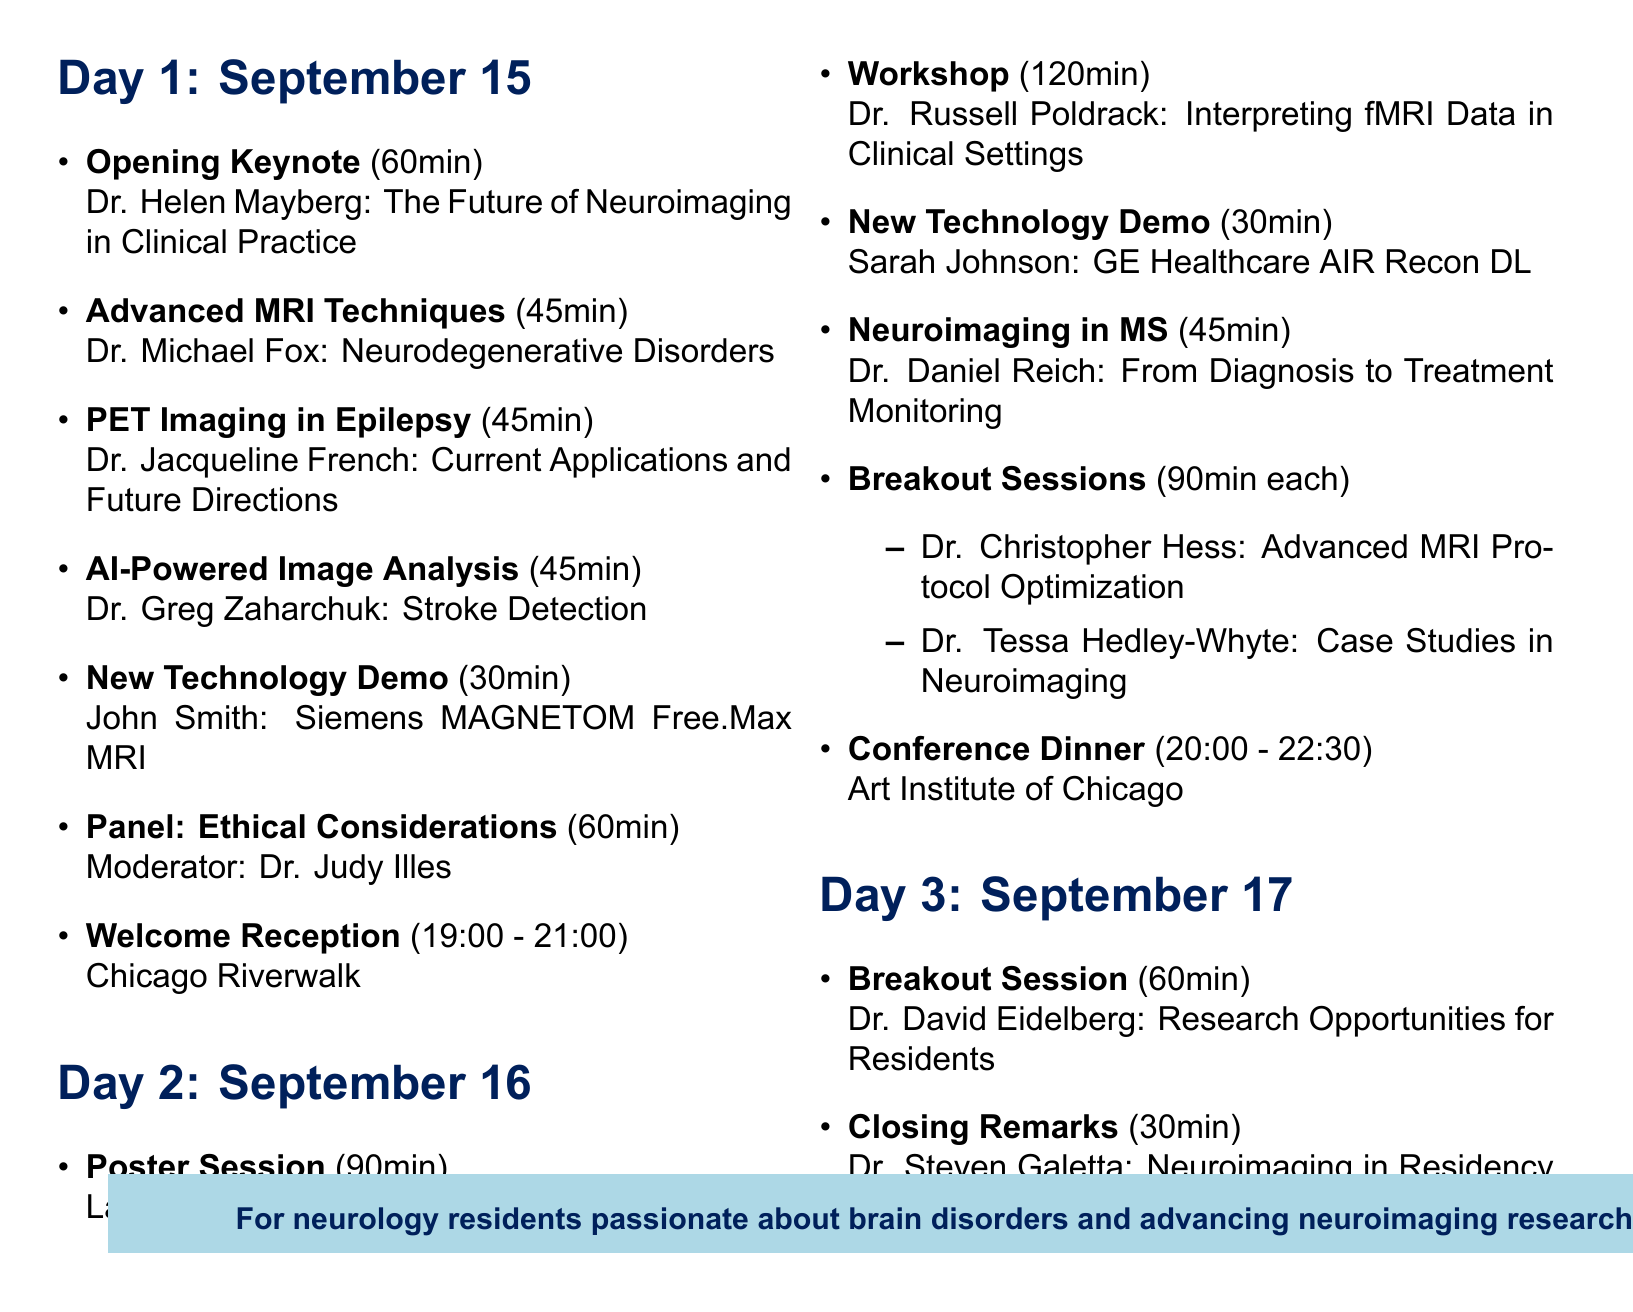What are the dates of the conference? The conference dates are mentioned clearly in the document as September 15-17, 2023.
Answer: September 15-17, 2023 Who is the speaker for the workshop on interpreting fMRI data? The document lists the facilitator for the workshop, which is Dr. Russell Poldrack from Stanford University.
Answer: Dr. Russell Poldrack How long is the closing remarks session? The duration of the closing remarks is specified in the document as 30 minutes.
Answer: 30 minutes Which venue will host the conference dinner? The venue for the conference dinner is stated as the Art Institute of Chicago in the document.
Answer: Art Institute of Chicago What is the duration of the poster session? The document specifies the poster session's duration as 90 minutes.
Answer: 90 minutes Who is moderating the panel discussion? The moderator for the panel discussion is mentioned as Dr. Judy Illes from the University of British Columbia.
Answer: Dr. Judy Illes What type of event is scheduled for September 15 from 19:00 to 21:00? The specific type of event during that time is the welcome reception, as stated in the document.
Answer: Welcome Reception How many breakout sessions are included in Day 2? The document indicates there are two breakout sessions planned for Day 2.
Answer: Two 